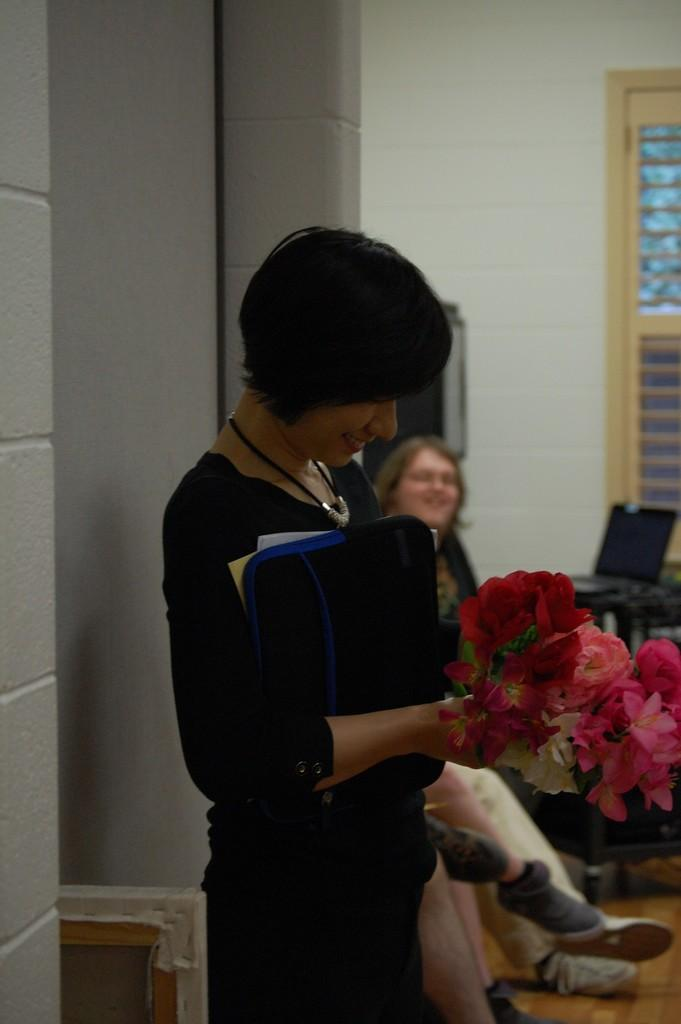What is the woman in the image doing? The woman is standing and smiling in the image. What is the woman holding in her hand? The woman is holding flowers in her hand. Can you describe the other woman in the image? There is another woman sitting beside the standing woman. What object can be seen on a table in the image? There is a laptop on a table in the image. What is visible in the background of the image? There is a wall visible in the image. What is the distance between the two women in the image? The provided facts do not give information about the distance between the two women, so it cannot be determined from the image. 